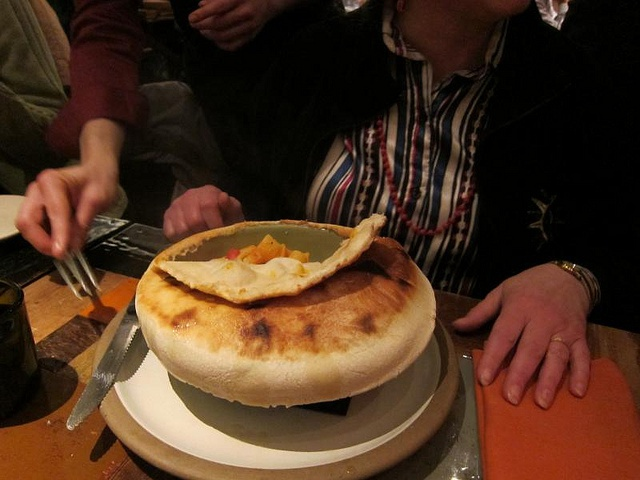Describe the objects in this image and their specific colors. I can see dining table in black, maroon, and brown tones, people in black, maroon, and brown tones, people in black, maroon, and brown tones, cup in black, maroon, and brown tones, and knife in black, gray, and maroon tones in this image. 